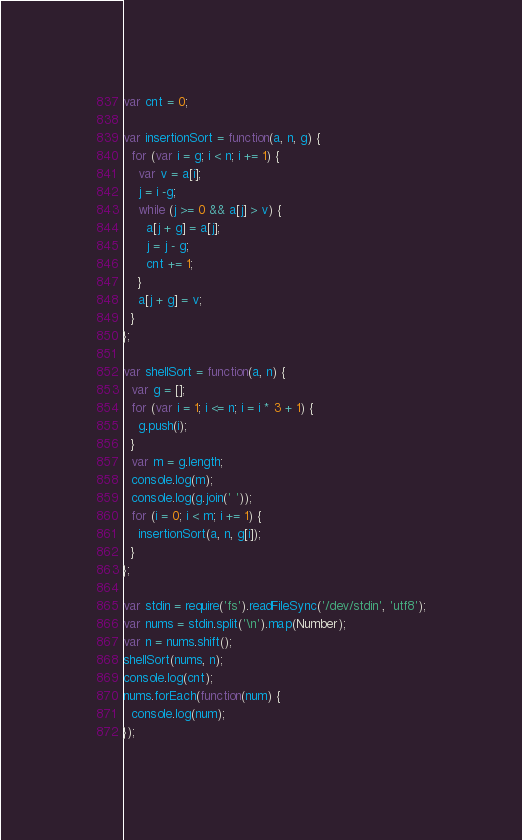Convert code to text. <code><loc_0><loc_0><loc_500><loc_500><_JavaScript_>var cnt = 0;

var insertionSort = function(a, n, g) {
  for (var i = g; i < n; i += 1) {
    var v = a[i];
    j = i -g;
    while (j >= 0 && a[j] > v) {
      a[j + g] = a[j];
      j = j - g;
      cnt += 1;
    }
    a[j + g] = v;
  }
};

var shellSort = function(a, n) {
  var g = [];
  for (var i = 1; i <= n; i = i * 3 + 1) {
    g.push(i);
  }
  var m = g.length;
  console.log(m);
  console.log(g.join(' '));
  for (i = 0; i < m; i += 1) {
    insertionSort(a, n, g[i]);
  }
};

var stdin = require('fs').readFileSync('/dev/stdin', 'utf8');
var nums = stdin.split('\n').map(Number);
var n = nums.shift();
shellSort(nums, n);
console.log(cnt);
nums.forEach(function(num) {
  console.log(num);
});</code> 